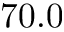<formula> <loc_0><loc_0><loc_500><loc_500>7 0 . 0</formula> 